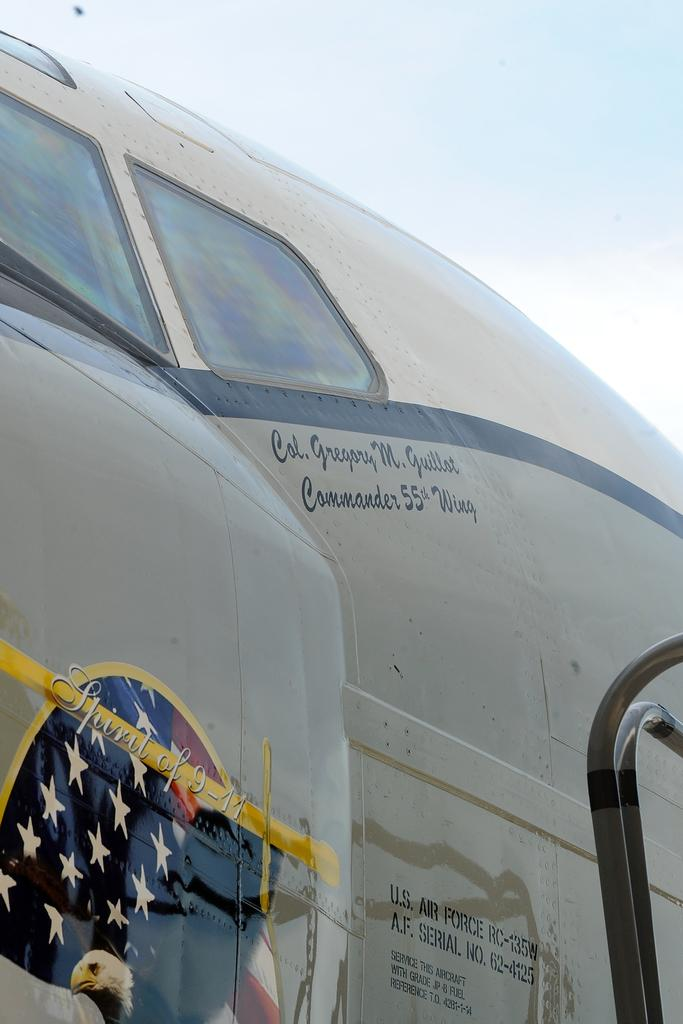What is the main subject of the zoom-in picture? The main subject of the zoom-in picture is an airplane. What can be seen in the background of the image? The sky is visible in the background of the image. What type of door can be seen on the airplane in the image? There is no door visible on the airplane in the image, as it is a zoom-in picture focused on the airplane itself. 